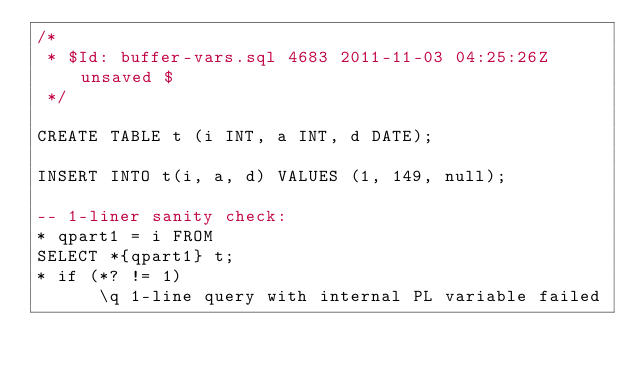Convert code to text. <code><loc_0><loc_0><loc_500><loc_500><_SQL_>/*
 * $Id: buffer-vars.sql 4683 2011-11-03 04:25:26Z unsaved $
 */

CREATE TABLE t (i INT, a INT, d DATE);

INSERT INTO t(i, a, d) VALUES (1, 149, null);

-- 1-liner sanity check:
* qpart1 = i FROM
SELECT *{qpart1} t;
* if (*? != 1)
      \q 1-line query with internal PL variable failed</code> 